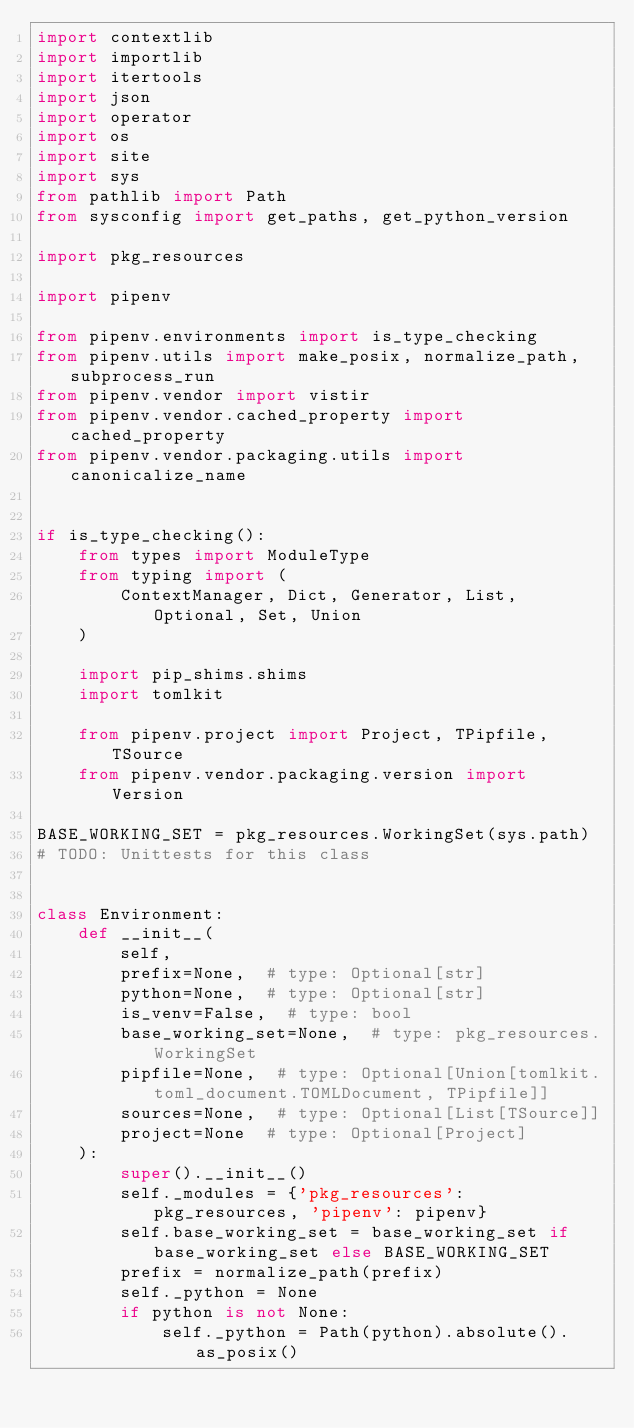<code> <loc_0><loc_0><loc_500><loc_500><_Python_>import contextlib
import importlib
import itertools
import json
import operator
import os
import site
import sys
from pathlib import Path
from sysconfig import get_paths, get_python_version

import pkg_resources

import pipenv

from pipenv.environments import is_type_checking
from pipenv.utils import make_posix, normalize_path, subprocess_run
from pipenv.vendor import vistir
from pipenv.vendor.cached_property import cached_property
from pipenv.vendor.packaging.utils import canonicalize_name


if is_type_checking():
    from types import ModuleType
    from typing import (
        ContextManager, Dict, Generator, List, Optional, Set, Union
    )

    import pip_shims.shims
    import tomlkit

    from pipenv.project import Project, TPipfile, TSource
    from pipenv.vendor.packaging.version import Version

BASE_WORKING_SET = pkg_resources.WorkingSet(sys.path)
# TODO: Unittests for this class


class Environment:
    def __init__(
        self,
        prefix=None,  # type: Optional[str]
        python=None,  # type: Optional[str]
        is_venv=False,  # type: bool
        base_working_set=None,  # type: pkg_resources.WorkingSet
        pipfile=None,  # type: Optional[Union[tomlkit.toml_document.TOMLDocument, TPipfile]]
        sources=None,  # type: Optional[List[TSource]]
        project=None  # type: Optional[Project]
    ):
        super().__init__()
        self._modules = {'pkg_resources': pkg_resources, 'pipenv': pipenv}
        self.base_working_set = base_working_set if base_working_set else BASE_WORKING_SET
        prefix = normalize_path(prefix)
        self._python = None
        if python is not None:
            self._python = Path(python).absolute().as_posix()</code> 